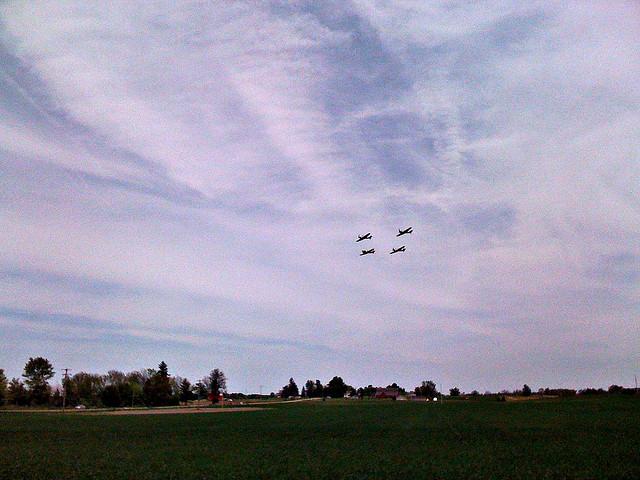What is in  the sky?
Short answer required. Planes. How many planes are flying in formation?
Give a very brief answer. 4. What is in the air?
Give a very brief answer. Airplanes. How many planes are there?
Be succinct. 4. Does this look like a sunny day?
Write a very short answer. Yes. How many birds are flying around?
Write a very short answer. 4. What type of jet is flying in the sky?
Write a very short answer. Air force. What is flying in the sky?
Be succinct. Planes. Are this planes flying in formation?
Quick response, please. Yes. Is there a water body nearby?
Short answer required. No. What are the people doing on the empty field?
Keep it brief. Standing. What is that in the sky?
Be succinct. Planes. Is there people in this scene?
Keep it brief. No. Is that a kite?
Short answer required. No. What are the black and white objects in the sky?
Write a very short answer. Planes. Are they flying a kite?
Give a very brief answer. No. Could this be Stonehenge?
Be succinct. No. Are there people in the photo?
Short answer required. No. What is in the sky?
Write a very short answer. Planes. Is that a lake?
Be succinct. No. Is there a bridge in the picture?
Give a very brief answer. No. What is moving in the picture?
Concise answer only. Airplanes. Is it raining?
Write a very short answer. No. Is this around a body of water?
Quick response, please. No. What color is the landscape?
Give a very brief answer. Green. Is this a beach?
Answer briefly. No. Is there an airplane in the sky?
Be succinct. Yes. Do the trees have leaf's?
Keep it brief. Yes. Would you want to take a nap here?
Quick response, please. No. Is that a dragon made of kites?
Concise answer only. No. How high is the hill?
Write a very short answer. Not high. What is the weather?
Short answer required. Cloudy. 